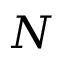<formula> <loc_0><loc_0><loc_500><loc_500>N</formula> 